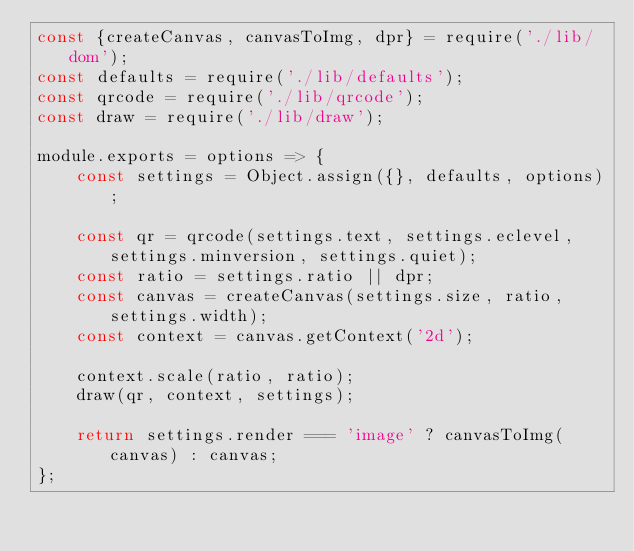<code> <loc_0><loc_0><loc_500><loc_500><_JavaScript_>const {createCanvas, canvasToImg, dpr} = require('./lib/dom');
const defaults = require('./lib/defaults');
const qrcode = require('./lib/qrcode');
const draw = require('./lib/draw');

module.exports = options => {
    const settings = Object.assign({}, defaults, options);

    const qr = qrcode(settings.text, settings.eclevel, settings.minversion, settings.quiet);
    const ratio = settings.ratio || dpr;
    const canvas = createCanvas(settings.size, ratio, settings.width);
    const context = canvas.getContext('2d');

    context.scale(ratio, ratio);
    draw(qr, context, settings);

    return settings.render === 'image' ? canvasToImg(canvas) : canvas;
};
</code> 